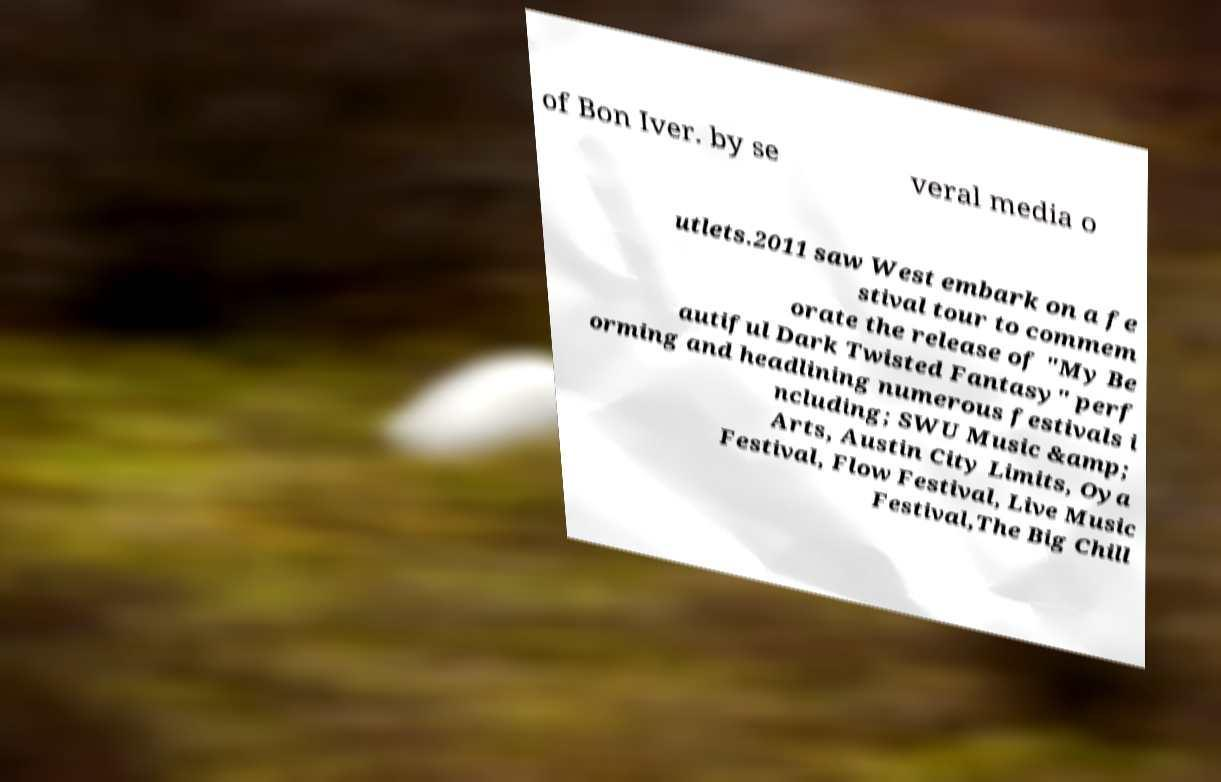Please identify and transcribe the text found in this image. of Bon Iver. by se veral media o utlets.2011 saw West embark on a fe stival tour to commem orate the release of "My Be autiful Dark Twisted Fantasy" perf orming and headlining numerous festivals i ncluding; SWU Music &amp; Arts, Austin City Limits, Oya Festival, Flow Festival, Live Music Festival,The Big Chill 